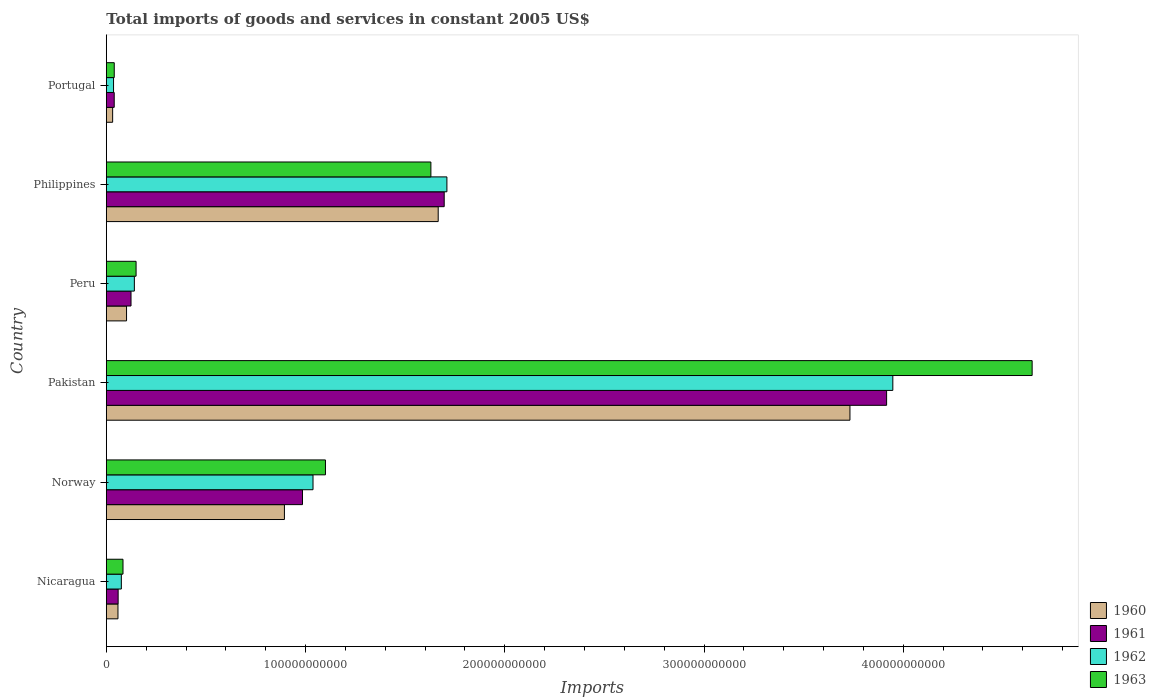How many different coloured bars are there?
Provide a short and direct response. 4. Are the number of bars per tick equal to the number of legend labels?
Keep it short and to the point. Yes. What is the total imports of goods and services in 1962 in Portugal?
Your answer should be very brief. 3.62e+09. Across all countries, what is the maximum total imports of goods and services in 1960?
Keep it short and to the point. 3.73e+11. Across all countries, what is the minimum total imports of goods and services in 1963?
Your answer should be compact. 3.98e+09. In which country was the total imports of goods and services in 1961 maximum?
Provide a short and direct response. Pakistan. In which country was the total imports of goods and services in 1962 minimum?
Provide a short and direct response. Portugal. What is the total total imports of goods and services in 1961 in the graph?
Offer a terse response. 6.82e+11. What is the difference between the total imports of goods and services in 1962 in Norway and that in Philippines?
Keep it short and to the point. -6.72e+1. What is the difference between the total imports of goods and services in 1961 in Norway and the total imports of goods and services in 1960 in Pakistan?
Provide a succinct answer. -2.75e+11. What is the average total imports of goods and services in 1960 per country?
Ensure brevity in your answer.  1.08e+11. What is the difference between the total imports of goods and services in 1960 and total imports of goods and services in 1962 in Norway?
Give a very brief answer. -1.44e+1. What is the ratio of the total imports of goods and services in 1961 in Nicaragua to that in Portugal?
Provide a succinct answer. 1.5. Is the difference between the total imports of goods and services in 1960 in Norway and Pakistan greater than the difference between the total imports of goods and services in 1962 in Norway and Pakistan?
Offer a very short reply. Yes. What is the difference between the highest and the second highest total imports of goods and services in 1961?
Make the answer very short. 2.22e+11. What is the difference between the highest and the lowest total imports of goods and services in 1960?
Offer a very short reply. 3.70e+11. Is the sum of the total imports of goods and services in 1960 in Pakistan and Peru greater than the maximum total imports of goods and services in 1961 across all countries?
Keep it short and to the point. No. Is it the case that in every country, the sum of the total imports of goods and services in 1960 and total imports of goods and services in 1961 is greater than the sum of total imports of goods and services in 1962 and total imports of goods and services in 1963?
Your answer should be compact. No. What does the 1st bar from the top in Pakistan represents?
Ensure brevity in your answer.  1963. Is it the case that in every country, the sum of the total imports of goods and services in 1961 and total imports of goods and services in 1963 is greater than the total imports of goods and services in 1960?
Your response must be concise. Yes. How many bars are there?
Offer a terse response. 24. Are all the bars in the graph horizontal?
Your response must be concise. Yes. How many countries are there in the graph?
Ensure brevity in your answer.  6. What is the difference between two consecutive major ticks on the X-axis?
Keep it short and to the point. 1.00e+11. Are the values on the major ticks of X-axis written in scientific E-notation?
Provide a succinct answer. No. Does the graph contain any zero values?
Offer a very short reply. No. Where does the legend appear in the graph?
Give a very brief answer. Bottom right. How many legend labels are there?
Provide a succinct answer. 4. How are the legend labels stacked?
Provide a succinct answer. Vertical. What is the title of the graph?
Give a very brief answer. Total imports of goods and services in constant 2005 US$. What is the label or title of the X-axis?
Make the answer very short. Imports. What is the label or title of the Y-axis?
Your answer should be compact. Country. What is the Imports of 1960 in Nicaragua?
Keep it short and to the point. 5.84e+09. What is the Imports of 1961 in Nicaragua?
Ensure brevity in your answer.  5.92e+09. What is the Imports of 1962 in Nicaragua?
Your response must be concise. 7.54e+09. What is the Imports of 1963 in Nicaragua?
Your answer should be very brief. 8.36e+09. What is the Imports of 1960 in Norway?
Offer a very short reply. 8.94e+1. What is the Imports in 1961 in Norway?
Give a very brief answer. 9.85e+1. What is the Imports in 1962 in Norway?
Offer a terse response. 1.04e+11. What is the Imports in 1963 in Norway?
Ensure brevity in your answer.  1.10e+11. What is the Imports in 1960 in Pakistan?
Give a very brief answer. 3.73e+11. What is the Imports in 1961 in Pakistan?
Keep it short and to the point. 3.92e+11. What is the Imports in 1962 in Pakistan?
Offer a terse response. 3.95e+11. What is the Imports of 1963 in Pakistan?
Give a very brief answer. 4.65e+11. What is the Imports of 1960 in Peru?
Give a very brief answer. 1.01e+1. What is the Imports of 1961 in Peru?
Your response must be concise. 1.24e+1. What is the Imports in 1962 in Peru?
Ensure brevity in your answer.  1.41e+1. What is the Imports in 1963 in Peru?
Offer a terse response. 1.49e+1. What is the Imports of 1960 in Philippines?
Your answer should be very brief. 1.67e+11. What is the Imports in 1961 in Philippines?
Make the answer very short. 1.70e+11. What is the Imports of 1962 in Philippines?
Give a very brief answer. 1.71e+11. What is the Imports of 1963 in Philippines?
Give a very brief answer. 1.63e+11. What is the Imports of 1960 in Portugal?
Offer a terse response. 3.17e+09. What is the Imports of 1961 in Portugal?
Ensure brevity in your answer.  3.96e+09. What is the Imports in 1962 in Portugal?
Offer a very short reply. 3.62e+09. What is the Imports in 1963 in Portugal?
Offer a very short reply. 3.98e+09. Across all countries, what is the maximum Imports of 1960?
Make the answer very short. 3.73e+11. Across all countries, what is the maximum Imports of 1961?
Make the answer very short. 3.92e+11. Across all countries, what is the maximum Imports of 1962?
Your answer should be compact. 3.95e+11. Across all countries, what is the maximum Imports in 1963?
Offer a terse response. 4.65e+11. Across all countries, what is the minimum Imports in 1960?
Your response must be concise. 3.17e+09. Across all countries, what is the minimum Imports in 1961?
Ensure brevity in your answer.  3.96e+09. Across all countries, what is the minimum Imports of 1962?
Make the answer very short. 3.62e+09. Across all countries, what is the minimum Imports in 1963?
Your answer should be very brief. 3.98e+09. What is the total Imports in 1960 in the graph?
Ensure brevity in your answer.  6.48e+11. What is the total Imports in 1961 in the graph?
Offer a terse response. 6.82e+11. What is the total Imports in 1962 in the graph?
Provide a short and direct response. 6.95e+11. What is the total Imports in 1963 in the graph?
Offer a terse response. 7.65e+11. What is the difference between the Imports in 1960 in Nicaragua and that in Norway?
Your response must be concise. -8.35e+1. What is the difference between the Imports of 1961 in Nicaragua and that in Norway?
Ensure brevity in your answer.  -9.25e+1. What is the difference between the Imports in 1962 in Nicaragua and that in Norway?
Your response must be concise. -9.62e+1. What is the difference between the Imports in 1963 in Nicaragua and that in Norway?
Your answer should be very brief. -1.02e+11. What is the difference between the Imports in 1960 in Nicaragua and that in Pakistan?
Provide a succinct answer. -3.67e+11. What is the difference between the Imports in 1961 in Nicaragua and that in Pakistan?
Provide a short and direct response. -3.86e+11. What is the difference between the Imports in 1962 in Nicaragua and that in Pakistan?
Keep it short and to the point. -3.87e+11. What is the difference between the Imports of 1963 in Nicaragua and that in Pakistan?
Offer a terse response. -4.56e+11. What is the difference between the Imports of 1960 in Nicaragua and that in Peru?
Offer a terse response. -4.30e+09. What is the difference between the Imports of 1961 in Nicaragua and that in Peru?
Provide a succinct answer. -6.46e+09. What is the difference between the Imports in 1962 in Nicaragua and that in Peru?
Offer a terse response. -6.53e+09. What is the difference between the Imports of 1963 in Nicaragua and that in Peru?
Provide a short and direct response. -6.57e+09. What is the difference between the Imports in 1960 in Nicaragua and that in Philippines?
Provide a succinct answer. -1.61e+11. What is the difference between the Imports in 1961 in Nicaragua and that in Philippines?
Your answer should be compact. -1.64e+11. What is the difference between the Imports in 1962 in Nicaragua and that in Philippines?
Make the answer very short. -1.63e+11. What is the difference between the Imports in 1963 in Nicaragua and that in Philippines?
Ensure brevity in your answer.  -1.55e+11. What is the difference between the Imports in 1960 in Nicaragua and that in Portugal?
Offer a terse response. 2.67e+09. What is the difference between the Imports in 1961 in Nicaragua and that in Portugal?
Your answer should be very brief. 1.97e+09. What is the difference between the Imports in 1962 in Nicaragua and that in Portugal?
Offer a terse response. 3.92e+09. What is the difference between the Imports of 1963 in Nicaragua and that in Portugal?
Keep it short and to the point. 4.39e+09. What is the difference between the Imports of 1960 in Norway and that in Pakistan?
Ensure brevity in your answer.  -2.84e+11. What is the difference between the Imports of 1961 in Norway and that in Pakistan?
Provide a short and direct response. -2.93e+11. What is the difference between the Imports of 1962 in Norway and that in Pakistan?
Offer a terse response. -2.91e+11. What is the difference between the Imports in 1963 in Norway and that in Pakistan?
Provide a short and direct response. -3.55e+11. What is the difference between the Imports in 1960 in Norway and that in Peru?
Provide a succinct answer. 7.92e+1. What is the difference between the Imports in 1961 in Norway and that in Peru?
Provide a succinct answer. 8.61e+1. What is the difference between the Imports of 1962 in Norway and that in Peru?
Offer a terse response. 8.97e+1. What is the difference between the Imports in 1963 in Norway and that in Peru?
Your response must be concise. 9.51e+1. What is the difference between the Imports of 1960 in Norway and that in Philippines?
Ensure brevity in your answer.  -7.72e+1. What is the difference between the Imports of 1961 in Norway and that in Philippines?
Provide a short and direct response. -7.11e+1. What is the difference between the Imports of 1962 in Norway and that in Philippines?
Offer a very short reply. -6.72e+1. What is the difference between the Imports in 1963 in Norway and that in Philippines?
Your answer should be compact. -5.29e+1. What is the difference between the Imports in 1960 in Norway and that in Portugal?
Offer a terse response. 8.62e+1. What is the difference between the Imports in 1961 in Norway and that in Portugal?
Provide a succinct answer. 9.45e+1. What is the difference between the Imports of 1962 in Norway and that in Portugal?
Ensure brevity in your answer.  1.00e+11. What is the difference between the Imports of 1963 in Norway and that in Portugal?
Your answer should be compact. 1.06e+11. What is the difference between the Imports in 1960 in Pakistan and that in Peru?
Offer a very short reply. 3.63e+11. What is the difference between the Imports in 1961 in Pakistan and that in Peru?
Give a very brief answer. 3.79e+11. What is the difference between the Imports of 1962 in Pakistan and that in Peru?
Provide a succinct answer. 3.81e+11. What is the difference between the Imports of 1963 in Pakistan and that in Peru?
Keep it short and to the point. 4.50e+11. What is the difference between the Imports in 1960 in Pakistan and that in Philippines?
Your response must be concise. 2.07e+11. What is the difference between the Imports of 1961 in Pakistan and that in Philippines?
Provide a succinct answer. 2.22e+11. What is the difference between the Imports in 1962 in Pakistan and that in Philippines?
Ensure brevity in your answer.  2.24e+11. What is the difference between the Imports of 1963 in Pakistan and that in Philippines?
Provide a succinct answer. 3.02e+11. What is the difference between the Imports in 1960 in Pakistan and that in Portugal?
Offer a very short reply. 3.70e+11. What is the difference between the Imports in 1961 in Pakistan and that in Portugal?
Ensure brevity in your answer.  3.88e+11. What is the difference between the Imports in 1962 in Pakistan and that in Portugal?
Keep it short and to the point. 3.91e+11. What is the difference between the Imports in 1963 in Pakistan and that in Portugal?
Ensure brevity in your answer.  4.61e+11. What is the difference between the Imports in 1960 in Peru and that in Philippines?
Keep it short and to the point. -1.56e+11. What is the difference between the Imports of 1961 in Peru and that in Philippines?
Your answer should be compact. -1.57e+11. What is the difference between the Imports of 1962 in Peru and that in Philippines?
Ensure brevity in your answer.  -1.57e+11. What is the difference between the Imports of 1963 in Peru and that in Philippines?
Offer a terse response. -1.48e+11. What is the difference between the Imports in 1960 in Peru and that in Portugal?
Your answer should be very brief. 6.98e+09. What is the difference between the Imports in 1961 in Peru and that in Portugal?
Keep it short and to the point. 8.43e+09. What is the difference between the Imports of 1962 in Peru and that in Portugal?
Your answer should be compact. 1.04e+1. What is the difference between the Imports of 1963 in Peru and that in Portugal?
Make the answer very short. 1.10e+1. What is the difference between the Imports of 1960 in Philippines and that in Portugal?
Keep it short and to the point. 1.63e+11. What is the difference between the Imports in 1961 in Philippines and that in Portugal?
Your answer should be compact. 1.66e+11. What is the difference between the Imports of 1962 in Philippines and that in Portugal?
Your answer should be compact. 1.67e+11. What is the difference between the Imports in 1963 in Philippines and that in Portugal?
Your answer should be very brief. 1.59e+11. What is the difference between the Imports in 1960 in Nicaragua and the Imports in 1961 in Norway?
Your response must be concise. -9.26e+1. What is the difference between the Imports of 1960 in Nicaragua and the Imports of 1962 in Norway?
Give a very brief answer. -9.79e+1. What is the difference between the Imports in 1960 in Nicaragua and the Imports in 1963 in Norway?
Ensure brevity in your answer.  -1.04e+11. What is the difference between the Imports in 1961 in Nicaragua and the Imports in 1962 in Norway?
Ensure brevity in your answer.  -9.78e+1. What is the difference between the Imports in 1961 in Nicaragua and the Imports in 1963 in Norway?
Provide a succinct answer. -1.04e+11. What is the difference between the Imports in 1962 in Nicaragua and the Imports in 1963 in Norway?
Your answer should be compact. -1.02e+11. What is the difference between the Imports in 1960 in Nicaragua and the Imports in 1961 in Pakistan?
Provide a short and direct response. -3.86e+11. What is the difference between the Imports in 1960 in Nicaragua and the Imports in 1962 in Pakistan?
Your response must be concise. -3.89e+11. What is the difference between the Imports of 1960 in Nicaragua and the Imports of 1963 in Pakistan?
Offer a very short reply. -4.59e+11. What is the difference between the Imports of 1961 in Nicaragua and the Imports of 1962 in Pakistan?
Give a very brief answer. -3.89e+11. What is the difference between the Imports of 1961 in Nicaragua and the Imports of 1963 in Pakistan?
Make the answer very short. -4.59e+11. What is the difference between the Imports of 1962 in Nicaragua and the Imports of 1963 in Pakistan?
Keep it short and to the point. -4.57e+11. What is the difference between the Imports in 1960 in Nicaragua and the Imports in 1961 in Peru?
Your answer should be compact. -6.55e+09. What is the difference between the Imports in 1960 in Nicaragua and the Imports in 1962 in Peru?
Make the answer very short. -8.22e+09. What is the difference between the Imports in 1960 in Nicaragua and the Imports in 1963 in Peru?
Make the answer very short. -9.09e+09. What is the difference between the Imports of 1961 in Nicaragua and the Imports of 1962 in Peru?
Provide a short and direct response. -8.14e+09. What is the difference between the Imports in 1961 in Nicaragua and the Imports in 1963 in Peru?
Make the answer very short. -9.00e+09. What is the difference between the Imports of 1962 in Nicaragua and the Imports of 1963 in Peru?
Your response must be concise. -7.39e+09. What is the difference between the Imports of 1960 in Nicaragua and the Imports of 1961 in Philippines?
Ensure brevity in your answer.  -1.64e+11. What is the difference between the Imports of 1960 in Nicaragua and the Imports of 1962 in Philippines?
Keep it short and to the point. -1.65e+11. What is the difference between the Imports in 1960 in Nicaragua and the Imports in 1963 in Philippines?
Your response must be concise. -1.57e+11. What is the difference between the Imports in 1961 in Nicaragua and the Imports in 1962 in Philippines?
Ensure brevity in your answer.  -1.65e+11. What is the difference between the Imports of 1961 in Nicaragua and the Imports of 1963 in Philippines?
Keep it short and to the point. -1.57e+11. What is the difference between the Imports of 1962 in Nicaragua and the Imports of 1963 in Philippines?
Keep it short and to the point. -1.55e+11. What is the difference between the Imports of 1960 in Nicaragua and the Imports of 1961 in Portugal?
Make the answer very short. 1.88e+09. What is the difference between the Imports in 1960 in Nicaragua and the Imports in 1962 in Portugal?
Give a very brief answer. 2.22e+09. What is the difference between the Imports in 1960 in Nicaragua and the Imports in 1963 in Portugal?
Give a very brief answer. 1.86e+09. What is the difference between the Imports of 1961 in Nicaragua and the Imports of 1962 in Portugal?
Ensure brevity in your answer.  2.30e+09. What is the difference between the Imports of 1961 in Nicaragua and the Imports of 1963 in Portugal?
Give a very brief answer. 1.95e+09. What is the difference between the Imports of 1962 in Nicaragua and the Imports of 1963 in Portugal?
Your answer should be very brief. 3.56e+09. What is the difference between the Imports in 1960 in Norway and the Imports in 1961 in Pakistan?
Your answer should be compact. -3.02e+11. What is the difference between the Imports of 1960 in Norway and the Imports of 1962 in Pakistan?
Your response must be concise. -3.05e+11. What is the difference between the Imports in 1960 in Norway and the Imports in 1963 in Pakistan?
Make the answer very short. -3.75e+11. What is the difference between the Imports in 1961 in Norway and the Imports in 1962 in Pakistan?
Keep it short and to the point. -2.96e+11. What is the difference between the Imports of 1961 in Norway and the Imports of 1963 in Pakistan?
Provide a short and direct response. -3.66e+11. What is the difference between the Imports of 1962 in Norway and the Imports of 1963 in Pakistan?
Provide a succinct answer. -3.61e+11. What is the difference between the Imports of 1960 in Norway and the Imports of 1961 in Peru?
Make the answer very short. 7.70e+1. What is the difference between the Imports in 1960 in Norway and the Imports in 1962 in Peru?
Make the answer very short. 7.53e+1. What is the difference between the Imports in 1960 in Norway and the Imports in 1963 in Peru?
Offer a very short reply. 7.45e+1. What is the difference between the Imports of 1961 in Norway and the Imports of 1962 in Peru?
Keep it short and to the point. 8.44e+1. What is the difference between the Imports in 1961 in Norway and the Imports in 1963 in Peru?
Keep it short and to the point. 8.35e+1. What is the difference between the Imports of 1962 in Norway and the Imports of 1963 in Peru?
Make the answer very short. 8.88e+1. What is the difference between the Imports of 1960 in Norway and the Imports of 1961 in Philippines?
Provide a short and direct response. -8.02e+1. What is the difference between the Imports of 1960 in Norway and the Imports of 1962 in Philippines?
Your answer should be very brief. -8.16e+1. What is the difference between the Imports of 1960 in Norway and the Imports of 1963 in Philippines?
Give a very brief answer. -7.35e+1. What is the difference between the Imports in 1961 in Norway and the Imports in 1962 in Philippines?
Offer a very short reply. -7.25e+1. What is the difference between the Imports in 1961 in Norway and the Imports in 1963 in Philippines?
Provide a short and direct response. -6.44e+1. What is the difference between the Imports in 1962 in Norway and the Imports in 1963 in Philippines?
Make the answer very short. -5.92e+1. What is the difference between the Imports in 1960 in Norway and the Imports in 1961 in Portugal?
Your answer should be very brief. 8.54e+1. What is the difference between the Imports in 1960 in Norway and the Imports in 1962 in Portugal?
Your answer should be compact. 8.58e+1. What is the difference between the Imports in 1960 in Norway and the Imports in 1963 in Portugal?
Your answer should be compact. 8.54e+1. What is the difference between the Imports of 1961 in Norway and the Imports of 1962 in Portugal?
Your answer should be very brief. 9.48e+1. What is the difference between the Imports of 1961 in Norway and the Imports of 1963 in Portugal?
Keep it short and to the point. 9.45e+1. What is the difference between the Imports of 1962 in Norway and the Imports of 1963 in Portugal?
Your answer should be very brief. 9.98e+1. What is the difference between the Imports in 1960 in Pakistan and the Imports in 1961 in Peru?
Ensure brevity in your answer.  3.61e+11. What is the difference between the Imports in 1960 in Pakistan and the Imports in 1962 in Peru?
Provide a short and direct response. 3.59e+11. What is the difference between the Imports of 1960 in Pakistan and the Imports of 1963 in Peru?
Keep it short and to the point. 3.58e+11. What is the difference between the Imports of 1961 in Pakistan and the Imports of 1962 in Peru?
Your response must be concise. 3.78e+11. What is the difference between the Imports in 1961 in Pakistan and the Imports in 1963 in Peru?
Provide a succinct answer. 3.77e+11. What is the difference between the Imports of 1962 in Pakistan and the Imports of 1963 in Peru?
Keep it short and to the point. 3.80e+11. What is the difference between the Imports of 1960 in Pakistan and the Imports of 1961 in Philippines?
Offer a terse response. 2.04e+11. What is the difference between the Imports in 1960 in Pakistan and the Imports in 1962 in Philippines?
Offer a very short reply. 2.02e+11. What is the difference between the Imports in 1960 in Pakistan and the Imports in 1963 in Philippines?
Your answer should be compact. 2.10e+11. What is the difference between the Imports of 1961 in Pakistan and the Imports of 1962 in Philippines?
Offer a very short reply. 2.21e+11. What is the difference between the Imports of 1961 in Pakistan and the Imports of 1963 in Philippines?
Keep it short and to the point. 2.29e+11. What is the difference between the Imports in 1962 in Pakistan and the Imports in 1963 in Philippines?
Keep it short and to the point. 2.32e+11. What is the difference between the Imports in 1960 in Pakistan and the Imports in 1961 in Portugal?
Your answer should be compact. 3.69e+11. What is the difference between the Imports in 1960 in Pakistan and the Imports in 1962 in Portugal?
Offer a very short reply. 3.70e+11. What is the difference between the Imports of 1960 in Pakistan and the Imports of 1963 in Portugal?
Offer a terse response. 3.69e+11. What is the difference between the Imports of 1961 in Pakistan and the Imports of 1962 in Portugal?
Provide a succinct answer. 3.88e+11. What is the difference between the Imports of 1961 in Pakistan and the Imports of 1963 in Portugal?
Give a very brief answer. 3.88e+11. What is the difference between the Imports of 1962 in Pakistan and the Imports of 1963 in Portugal?
Offer a very short reply. 3.91e+11. What is the difference between the Imports in 1960 in Peru and the Imports in 1961 in Philippines?
Offer a terse response. -1.59e+11. What is the difference between the Imports in 1960 in Peru and the Imports in 1962 in Philippines?
Give a very brief answer. -1.61e+11. What is the difference between the Imports of 1960 in Peru and the Imports of 1963 in Philippines?
Give a very brief answer. -1.53e+11. What is the difference between the Imports of 1961 in Peru and the Imports of 1962 in Philippines?
Offer a very short reply. -1.59e+11. What is the difference between the Imports of 1961 in Peru and the Imports of 1963 in Philippines?
Your answer should be very brief. -1.51e+11. What is the difference between the Imports of 1962 in Peru and the Imports of 1963 in Philippines?
Provide a succinct answer. -1.49e+11. What is the difference between the Imports in 1960 in Peru and the Imports in 1961 in Portugal?
Keep it short and to the point. 6.19e+09. What is the difference between the Imports in 1960 in Peru and the Imports in 1962 in Portugal?
Your response must be concise. 6.53e+09. What is the difference between the Imports of 1960 in Peru and the Imports of 1963 in Portugal?
Ensure brevity in your answer.  6.17e+09. What is the difference between the Imports of 1961 in Peru and the Imports of 1962 in Portugal?
Offer a very short reply. 8.77e+09. What is the difference between the Imports of 1961 in Peru and the Imports of 1963 in Portugal?
Make the answer very short. 8.41e+09. What is the difference between the Imports in 1962 in Peru and the Imports in 1963 in Portugal?
Provide a short and direct response. 1.01e+1. What is the difference between the Imports of 1960 in Philippines and the Imports of 1961 in Portugal?
Your answer should be very brief. 1.63e+11. What is the difference between the Imports in 1960 in Philippines and the Imports in 1962 in Portugal?
Offer a terse response. 1.63e+11. What is the difference between the Imports of 1960 in Philippines and the Imports of 1963 in Portugal?
Your response must be concise. 1.63e+11. What is the difference between the Imports in 1961 in Philippines and the Imports in 1962 in Portugal?
Offer a terse response. 1.66e+11. What is the difference between the Imports in 1961 in Philippines and the Imports in 1963 in Portugal?
Your answer should be very brief. 1.66e+11. What is the difference between the Imports in 1962 in Philippines and the Imports in 1963 in Portugal?
Your answer should be compact. 1.67e+11. What is the average Imports in 1960 per country?
Your answer should be compact. 1.08e+11. What is the average Imports in 1961 per country?
Make the answer very short. 1.14e+11. What is the average Imports of 1962 per country?
Keep it short and to the point. 1.16e+11. What is the average Imports of 1963 per country?
Provide a succinct answer. 1.27e+11. What is the difference between the Imports of 1960 and Imports of 1961 in Nicaragua?
Give a very brief answer. -8.34e+07. What is the difference between the Imports in 1960 and Imports in 1962 in Nicaragua?
Your response must be concise. -1.70e+09. What is the difference between the Imports of 1960 and Imports of 1963 in Nicaragua?
Your answer should be very brief. -2.52e+09. What is the difference between the Imports in 1961 and Imports in 1962 in Nicaragua?
Offer a terse response. -1.61e+09. What is the difference between the Imports in 1961 and Imports in 1963 in Nicaragua?
Offer a terse response. -2.44e+09. What is the difference between the Imports in 1962 and Imports in 1963 in Nicaragua?
Your answer should be compact. -8.25e+08. What is the difference between the Imports in 1960 and Imports in 1961 in Norway?
Offer a terse response. -9.07e+09. What is the difference between the Imports of 1960 and Imports of 1962 in Norway?
Your response must be concise. -1.44e+1. What is the difference between the Imports of 1960 and Imports of 1963 in Norway?
Provide a short and direct response. -2.06e+1. What is the difference between the Imports in 1961 and Imports in 1962 in Norway?
Offer a very short reply. -5.28e+09. What is the difference between the Imports in 1961 and Imports in 1963 in Norway?
Keep it short and to the point. -1.15e+1. What is the difference between the Imports of 1962 and Imports of 1963 in Norway?
Keep it short and to the point. -6.24e+09. What is the difference between the Imports in 1960 and Imports in 1961 in Pakistan?
Make the answer very short. -1.84e+1. What is the difference between the Imports in 1960 and Imports in 1962 in Pakistan?
Keep it short and to the point. -2.15e+1. What is the difference between the Imports of 1960 and Imports of 1963 in Pakistan?
Make the answer very short. -9.14e+1. What is the difference between the Imports of 1961 and Imports of 1962 in Pakistan?
Your answer should be compact. -3.12e+09. What is the difference between the Imports of 1961 and Imports of 1963 in Pakistan?
Offer a terse response. -7.30e+1. What is the difference between the Imports of 1962 and Imports of 1963 in Pakistan?
Keep it short and to the point. -6.99e+1. What is the difference between the Imports in 1960 and Imports in 1961 in Peru?
Your answer should be very brief. -2.24e+09. What is the difference between the Imports of 1960 and Imports of 1962 in Peru?
Your answer should be compact. -3.92e+09. What is the difference between the Imports of 1960 and Imports of 1963 in Peru?
Your response must be concise. -4.78e+09. What is the difference between the Imports in 1961 and Imports in 1962 in Peru?
Your answer should be very brief. -1.68e+09. What is the difference between the Imports in 1961 and Imports in 1963 in Peru?
Your response must be concise. -2.54e+09. What is the difference between the Imports of 1962 and Imports of 1963 in Peru?
Provide a succinct answer. -8.62e+08. What is the difference between the Imports of 1960 and Imports of 1961 in Philippines?
Offer a very short reply. -3.01e+09. What is the difference between the Imports in 1960 and Imports in 1962 in Philippines?
Offer a very short reply. -4.37e+09. What is the difference between the Imports in 1960 and Imports in 1963 in Philippines?
Provide a short and direct response. 3.68e+09. What is the difference between the Imports of 1961 and Imports of 1962 in Philippines?
Your answer should be compact. -1.36e+09. What is the difference between the Imports of 1961 and Imports of 1963 in Philippines?
Make the answer very short. 6.69e+09. What is the difference between the Imports in 1962 and Imports in 1963 in Philippines?
Offer a very short reply. 8.04e+09. What is the difference between the Imports in 1960 and Imports in 1961 in Portugal?
Offer a terse response. -7.89e+08. What is the difference between the Imports in 1960 and Imports in 1962 in Portugal?
Keep it short and to the point. -4.52e+08. What is the difference between the Imports in 1960 and Imports in 1963 in Portugal?
Ensure brevity in your answer.  -8.09e+08. What is the difference between the Imports of 1961 and Imports of 1962 in Portugal?
Ensure brevity in your answer.  3.37e+08. What is the difference between the Imports of 1961 and Imports of 1963 in Portugal?
Make the answer very short. -2.01e+07. What is the difference between the Imports in 1962 and Imports in 1963 in Portugal?
Offer a very short reply. -3.57e+08. What is the ratio of the Imports of 1960 in Nicaragua to that in Norway?
Your answer should be compact. 0.07. What is the ratio of the Imports in 1961 in Nicaragua to that in Norway?
Give a very brief answer. 0.06. What is the ratio of the Imports in 1962 in Nicaragua to that in Norway?
Your response must be concise. 0.07. What is the ratio of the Imports of 1963 in Nicaragua to that in Norway?
Keep it short and to the point. 0.08. What is the ratio of the Imports in 1960 in Nicaragua to that in Pakistan?
Provide a short and direct response. 0.02. What is the ratio of the Imports of 1961 in Nicaragua to that in Pakistan?
Provide a succinct answer. 0.02. What is the ratio of the Imports in 1962 in Nicaragua to that in Pakistan?
Your answer should be compact. 0.02. What is the ratio of the Imports in 1963 in Nicaragua to that in Pakistan?
Offer a terse response. 0.02. What is the ratio of the Imports in 1960 in Nicaragua to that in Peru?
Keep it short and to the point. 0.58. What is the ratio of the Imports of 1961 in Nicaragua to that in Peru?
Your response must be concise. 0.48. What is the ratio of the Imports of 1962 in Nicaragua to that in Peru?
Give a very brief answer. 0.54. What is the ratio of the Imports in 1963 in Nicaragua to that in Peru?
Make the answer very short. 0.56. What is the ratio of the Imports of 1960 in Nicaragua to that in Philippines?
Offer a terse response. 0.04. What is the ratio of the Imports in 1961 in Nicaragua to that in Philippines?
Offer a very short reply. 0.03. What is the ratio of the Imports in 1962 in Nicaragua to that in Philippines?
Your response must be concise. 0.04. What is the ratio of the Imports of 1963 in Nicaragua to that in Philippines?
Offer a terse response. 0.05. What is the ratio of the Imports of 1960 in Nicaragua to that in Portugal?
Your response must be concise. 1.84. What is the ratio of the Imports of 1961 in Nicaragua to that in Portugal?
Your answer should be compact. 1.5. What is the ratio of the Imports in 1962 in Nicaragua to that in Portugal?
Ensure brevity in your answer.  2.08. What is the ratio of the Imports in 1963 in Nicaragua to that in Portugal?
Ensure brevity in your answer.  2.1. What is the ratio of the Imports of 1960 in Norway to that in Pakistan?
Provide a short and direct response. 0.24. What is the ratio of the Imports of 1961 in Norway to that in Pakistan?
Make the answer very short. 0.25. What is the ratio of the Imports in 1962 in Norway to that in Pakistan?
Offer a terse response. 0.26. What is the ratio of the Imports in 1963 in Norway to that in Pakistan?
Your answer should be compact. 0.24. What is the ratio of the Imports of 1960 in Norway to that in Peru?
Give a very brief answer. 8.81. What is the ratio of the Imports of 1961 in Norway to that in Peru?
Give a very brief answer. 7.95. What is the ratio of the Imports in 1962 in Norway to that in Peru?
Ensure brevity in your answer.  7.38. What is the ratio of the Imports in 1963 in Norway to that in Peru?
Offer a terse response. 7.37. What is the ratio of the Imports of 1960 in Norway to that in Philippines?
Your answer should be compact. 0.54. What is the ratio of the Imports of 1961 in Norway to that in Philippines?
Keep it short and to the point. 0.58. What is the ratio of the Imports of 1962 in Norway to that in Philippines?
Your answer should be very brief. 0.61. What is the ratio of the Imports of 1963 in Norway to that in Philippines?
Ensure brevity in your answer.  0.68. What is the ratio of the Imports of 1960 in Norway to that in Portugal?
Offer a terse response. 28.23. What is the ratio of the Imports of 1961 in Norway to that in Portugal?
Keep it short and to the point. 24.89. What is the ratio of the Imports in 1962 in Norway to that in Portugal?
Provide a short and direct response. 28.66. What is the ratio of the Imports in 1963 in Norway to that in Portugal?
Your answer should be very brief. 27.66. What is the ratio of the Imports of 1960 in Pakistan to that in Peru?
Offer a terse response. 36.79. What is the ratio of the Imports of 1961 in Pakistan to that in Peru?
Ensure brevity in your answer.  31.62. What is the ratio of the Imports in 1962 in Pakistan to that in Peru?
Your answer should be very brief. 28.07. What is the ratio of the Imports of 1963 in Pakistan to that in Peru?
Keep it short and to the point. 31.13. What is the ratio of the Imports in 1960 in Pakistan to that in Philippines?
Keep it short and to the point. 2.24. What is the ratio of the Imports in 1961 in Pakistan to that in Philippines?
Offer a terse response. 2.31. What is the ratio of the Imports of 1962 in Pakistan to that in Philippines?
Give a very brief answer. 2.31. What is the ratio of the Imports in 1963 in Pakistan to that in Philippines?
Provide a succinct answer. 2.85. What is the ratio of the Imports of 1960 in Pakistan to that in Portugal?
Offer a very short reply. 117.86. What is the ratio of the Imports of 1961 in Pakistan to that in Portugal?
Your answer should be very brief. 99. What is the ratio of the Imports in 1962 in Pakistan to that in Portugal?
Give a very brief answer. 109.08. What is the ratio of the Imports of 1963 in Pakistan to that in Portugal?
Keep it short and to the point. 116.87. What is the ratio of the Imports in 1960 in Peru to that in Philippines?
Provide a short and direct response. 0.06. What is the ratio of the Imports in 1961 in Peru to that in Philippines?
Provide a short and direct response. 0.07. What is the ratio of the Imports in 1962 in Peru to that in Philippines?
Provide a succinct answer. 0.08. What is the ratio of the Imports in 1963 in Peru to that in Philippines?
Give a very brief answer. 0.09. What is the ratio of the Imports of 1960 in Peru to that in Portugal?
Offer a very short reply. 3.2. What is the ratio of the Imports in 1961 in Peru to that in Portugal?
Your answer should be compact. 3.13. What is the ratio of the Imports in 1962 in Peru to that in Portugal?
Offer a very short reply. 3.89. What is the ratio of the Imports of 1963 in Peru to that in Portugal?
Make the answer very short. 3.75. What is the ratio of the Imports of 1960 in Philippines to that in Portugal?
Ensure brevity in your answer.  52.6. What is the ratio of the Imports of 1961 in Philippines to that in Portugal?
Offer a terse response. 42.87. What is the ratio of the Imports in 1962 in Philippines to that in Portugal?
Keep it short and to the point. 47.23. What is the ratio of the Imports in 1963 in Philippines to that in Portugal?
Your answer should be compact. 40.97. What is the difference between the highest and the second highest Imports in 1960?
Your answer should be very brief. 2.07e+11. What is the difference between the highest and the second highest Imports in 1961?
Your answer should be compact. 2.22e+11. What is the difference between the highest and the second highest Imports in 1962?
Make the answer very short. 2.24e+11. What is the difference between the highest and the second highest Imports in 1963?
Give a very brief answer. 3.02e+11. What is the difference between the highest and the lowest Imports in 1960?
Your answer should be very brief. 3.70e+11. What is the difference between the highest and the lowest Imports in 1961?
Provide a succinct answer. 3.88e+11. What is the difference between the highest and the lowest Imports in 1962?
Provide a short and direct response. 3.91e+11. What is the difference between the highest and the lowest Imports in 1963?
Make the answer very short. 4.61e+11. 